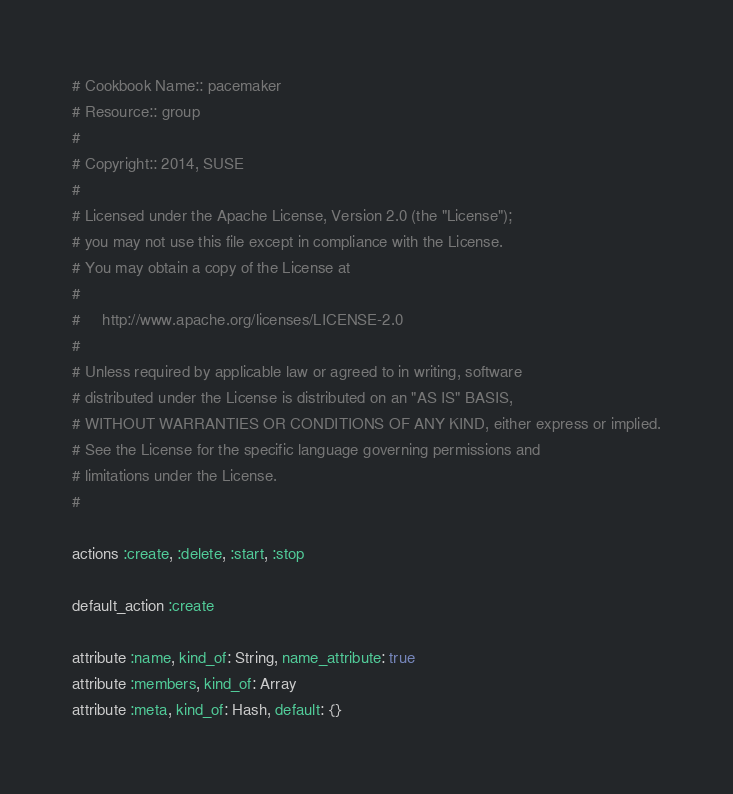<code> <loc_0><loc_0><loc_500><loc_500><_Ruby_># Cookbook Name:: pacemaker
# Resource:: group
#
# Copyright:: 2014, SUSE
#
# Licensed under the Apache License, Version 2.0 (the "License");
# you may not use this file except in compliance with the License.
# You may obtain a copy of the License at
#
#     http://www.apache.org/licenses/LICENSE-2.0
#
# Unless required by applicable law or agreed to in writing, software
# distributed under the License is distributed on an "AS IS" BASIS,
# WITHOUT WARRANTIES OR CONDITIONS OF ANY KIND, either express or implied.
# See the License for the specific language governing permissions and
# limitations under the License.
#

actions :create, :delete, :start, :stop

default_action :create

attribute :name, kind_of: String, name_attribute: true
attribute :members, kind_of: Array
attribute :meta, kind_of: Hash, default: {}
</code> 